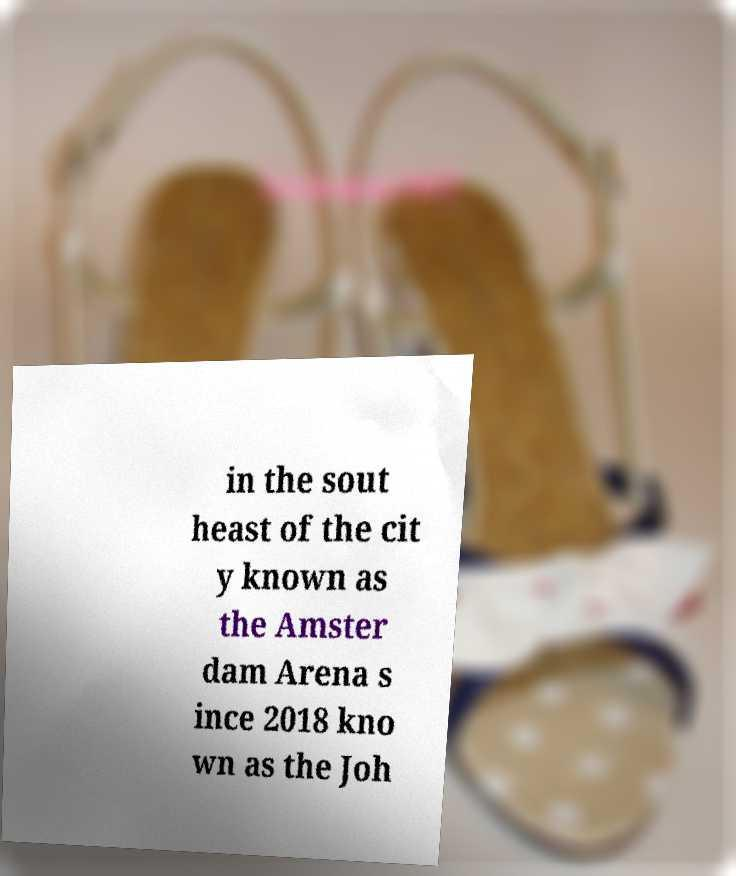Can you accurately transcribe the text from the provided image for me? in the sout heast of the cit y known as the Amster dam Arena s ince 2018 kno wn as the Joh 